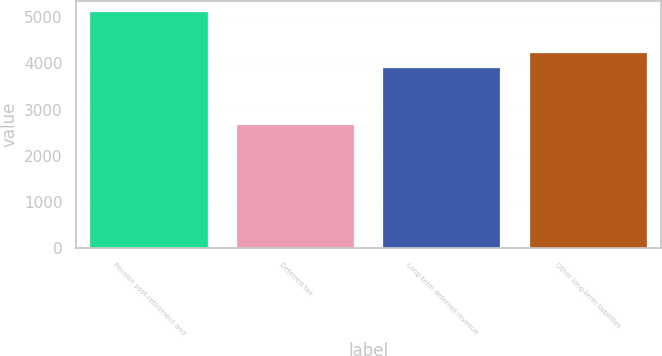Convert chart. <chart><loc_0><loc_0><loc_500><loc_500><bar_chart><fcel>Pension post-retirement and<fcel>Deferred tax<fcel>Long-term deferred revenue<fcel>Other long-term liabilities<nl><fcel>5098<fcel>2668<fcel>3907<fcel>4218<nl></chart> 